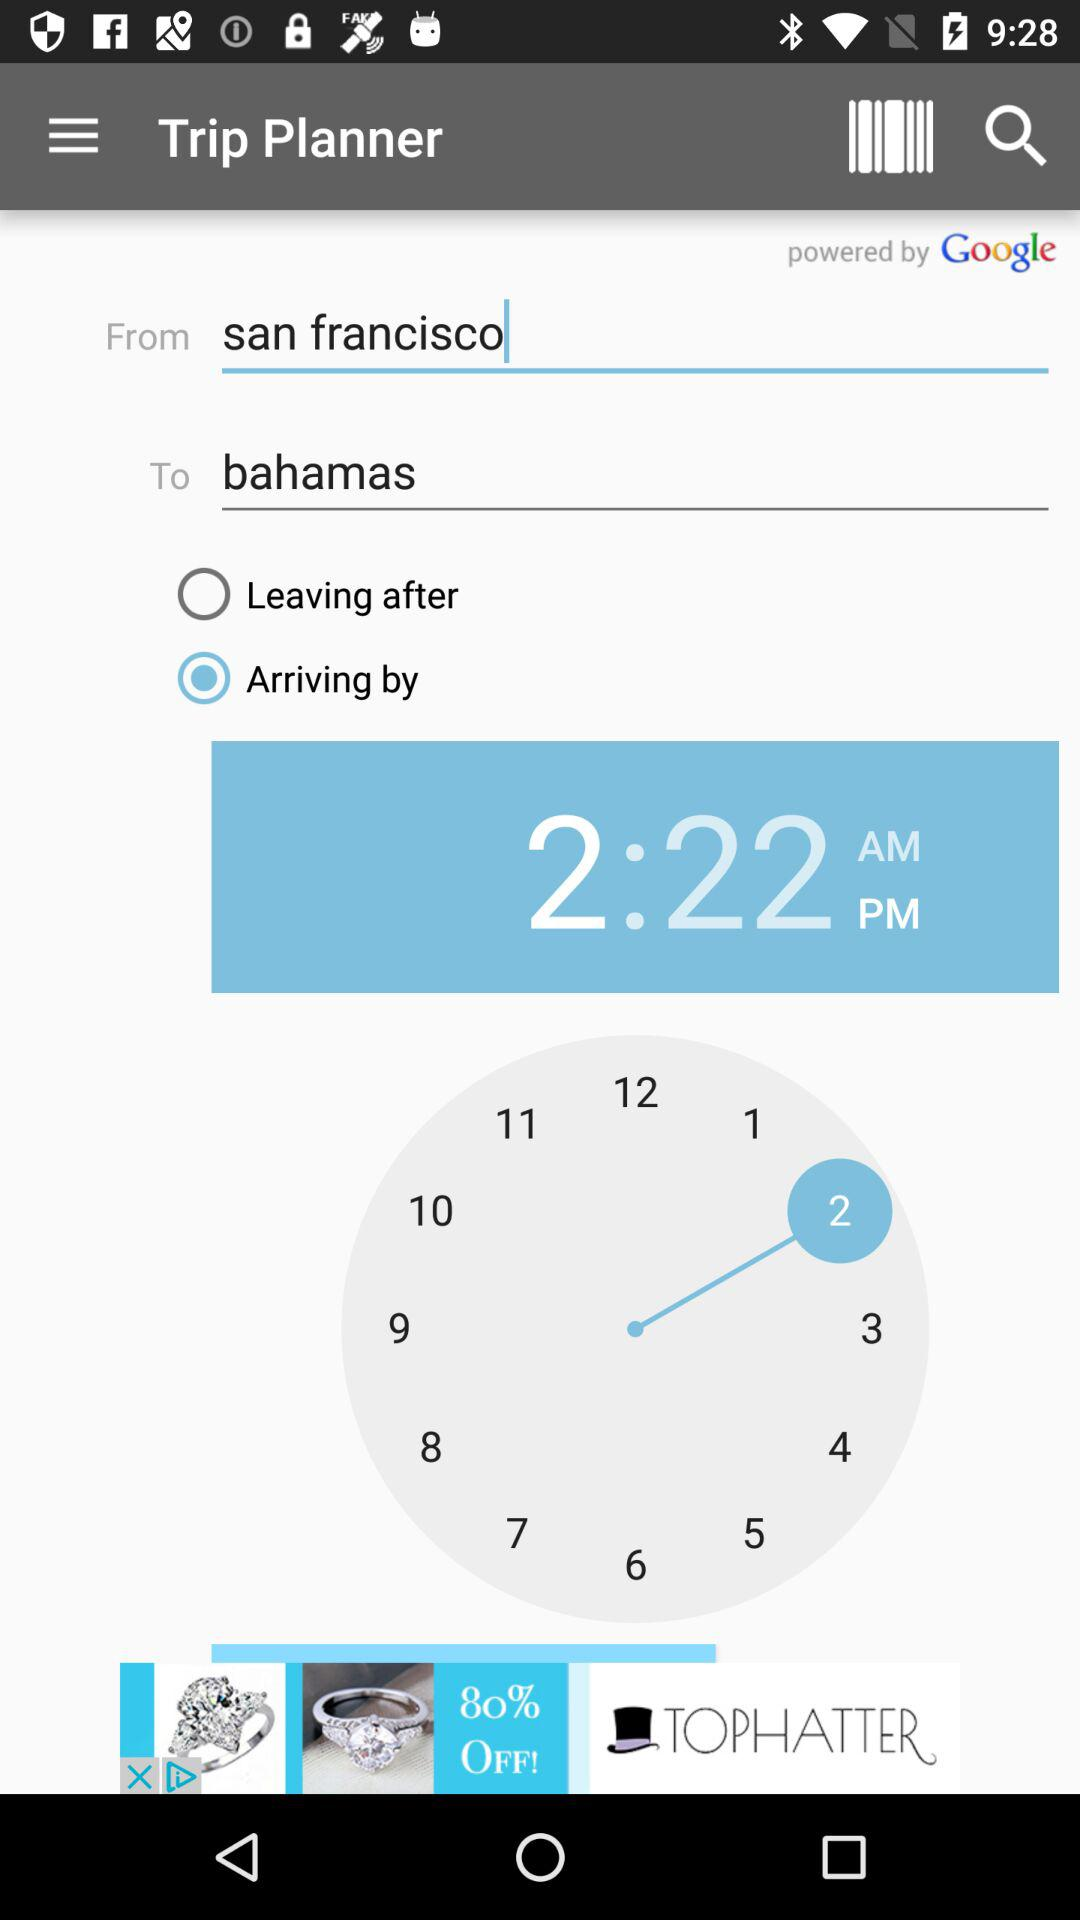What is the selected time on the clock? The selected time on the clock is 2:22 PM. 